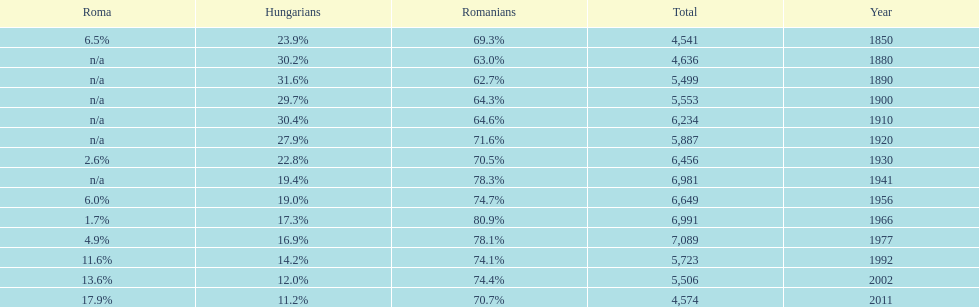Which year had the top percentage in romanian population? 1966. 